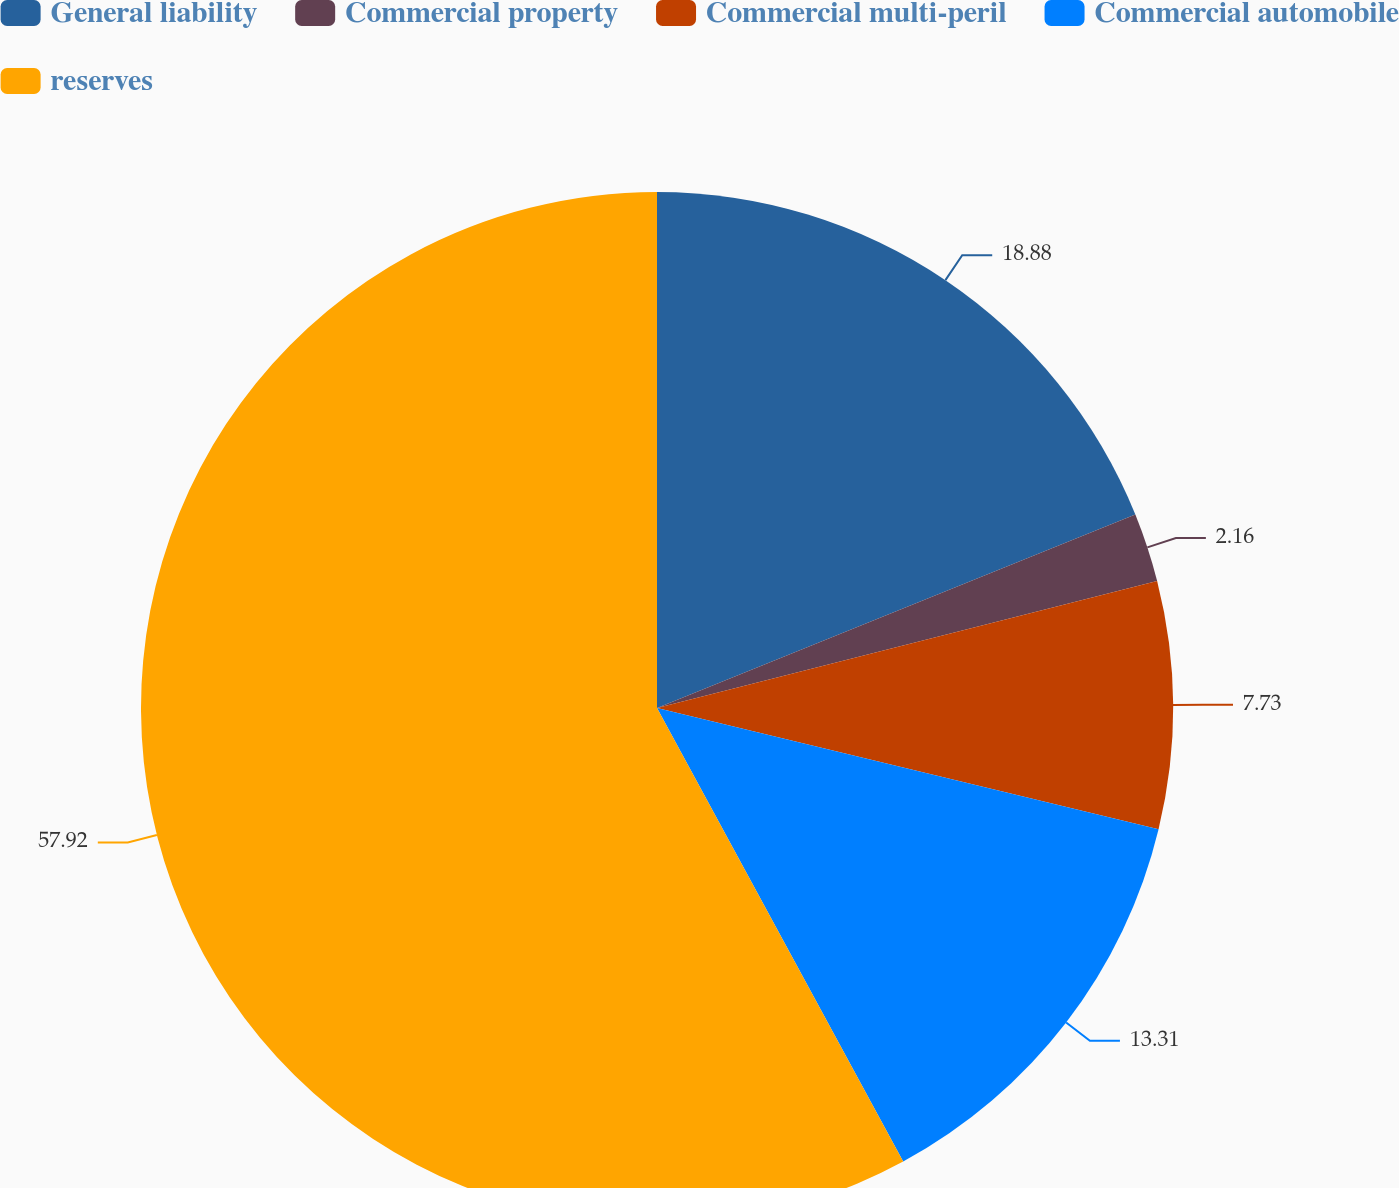<chart> <loc_0><loc_0><loc_500><loc_500><pie_chart><fcel>General liability<fcel>Commercial property<fcel>Commercial multi-peril<fcel>Commercial automobile<fcel>reserves<nl><fcel>18.88%<fcel>2.16%<fcel>7.73%<fcel>13.31%<fcel>57.91%<nl></chart> 